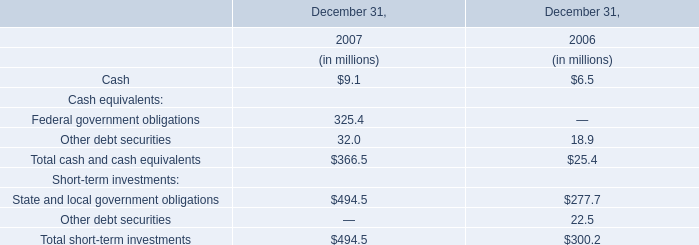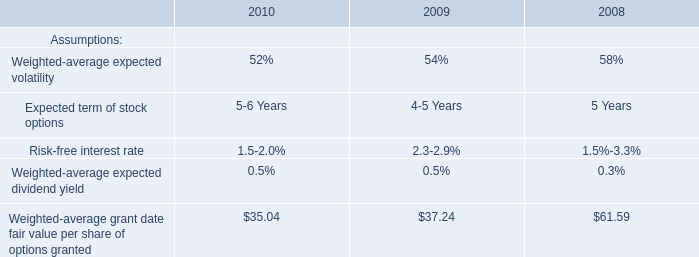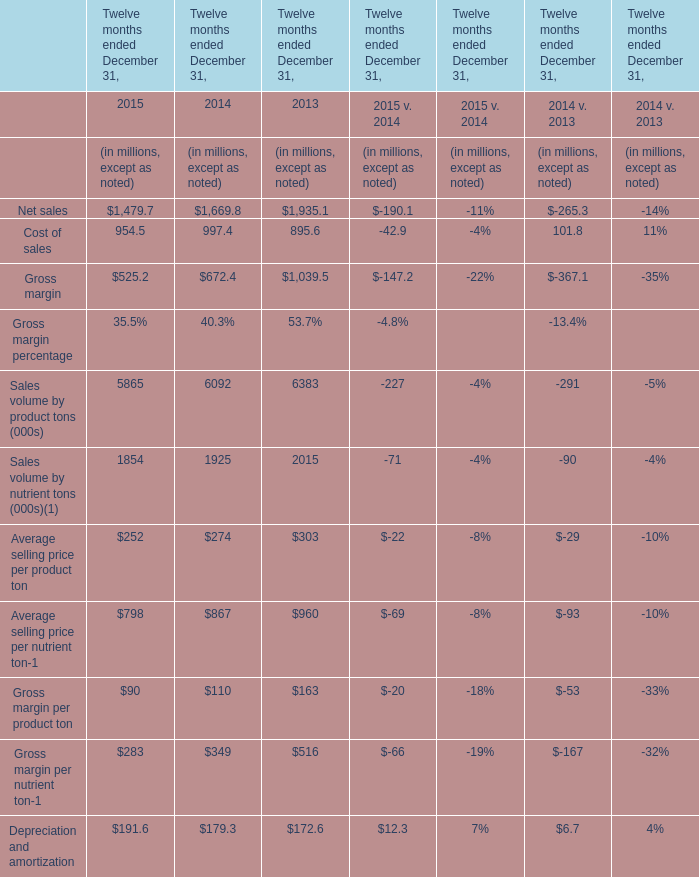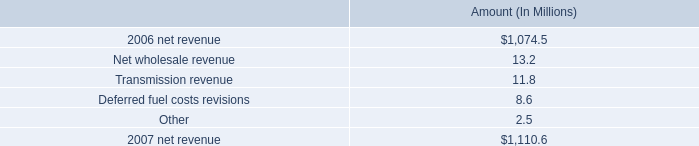What will Gross margin reach in 2016 if it continues to grow at its current rate? (in millions) 
Computations: ((1 + ((525.2 - 672.4) / 672.4)) * 525.2)
Answer: 410.22463. 